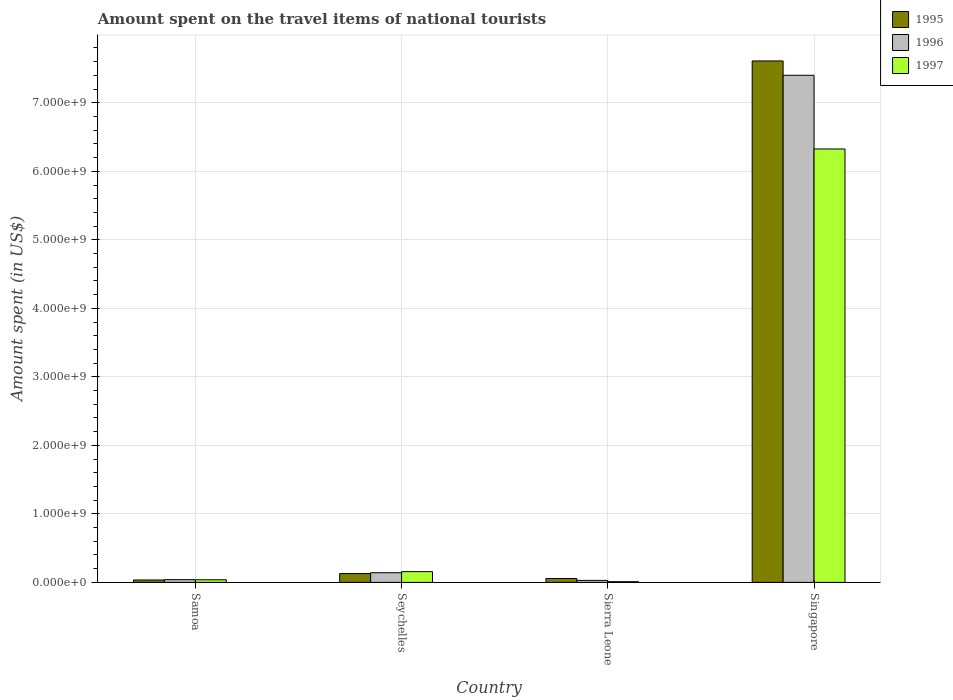Are the number of bars on each tick of the X-axis equal?
Offer a very short reply. Yes. How many bars are there on the 3rd tick from the left?
Make the answer very short. 3. What is the label of the 3rd group of bars from the left?
Keep it short and to the point. Sierra Leone. What is the amount spent on the travel items of national tourists in 1995 in Samoa?
Keep it short and to the point. 3.50e+07. Across all countries, what is the maximum amount spent on the travel items of national tourists in 1996?
Your answer should be very brief. 7.40e+09. Across all countries, what is the minimum amount spent on the travel items of national tourists in 1997?
Ensure brevity in your answer.  1.00e+07. In which country was the amount spent on the travel items of national tourists in 1995 maximum?
Your answer should be very brief. Singapore. In which country was the amount spent on the travel items of national tourists in 1997 minimum?
Offer a terse response. Sierra Leone. What is the total amount spent on the travel items of national tourists in 1995 in the graph?
Your answer should be very brief. 7.83e+09. What is the difference between the amount spent on the travel items of national tourists in 1997 in Samoa and that in Singapore?
Provide a short and direct response. -6.29e+09. What is the difference between the amount spent on the travel items of national tourists in 1996 in Sierra Leone and the amount spent on the travel items of national tourists in 1995 in Samoa?
Your response must be concise. -6.00e+06. What is the average amount spent on the travel items of national tourists in 1996 per country?
Provide a succinct answer. 1.90e+09. What is the difference between the amount spent on the travel items of national tourists of/in 1997 and amount spent on the travel items of national tourists of/in 1995 in Sierra Leone?
Keep it short and to the point. -4.70e+07. What is the ratio of the amount spent on the travel items of national tourists in 1995 in Seychelles to that in Sierra Leone?
Ensure brevity in your answer.  2.26. Is the amount spent on the travel items of national tourists in 1996 in Sierra Leone less than that in Singapore?
Ensure brevity in your answer.  Yes. What is the difference between the highest and the second highest amount spent on the travel items of national tourists in 1996?
Offer a terse response. 7.36e+09. What is the difference between the highest and the lowest amount spent on the travel items of national tourists in 1996?
Provide a short and direct response. 7.37e+09. Is the sum of the amount spent on the travel items of national tourists in 1997 in Samoa and Sierra Leone greater than the maximum amount spent on the travel items of national tourists in 1996 across all countries?
Offer a very short reply. No. What does the 2nd bar from the right in Singapore represents?
Provide a succinct answer. 1996. Is it the case that in every country, the sum of the amount spent on the travel items of national tourists in 1997 and amount spent on the travel items of national tourists in 1995 is greater than the amount spent on the travel items of national tourists in 1996?
Your answer should be very brief. Yes. Are all the bars in the graph horizontal?
Make the answer very short. No. What is the title of the graph?
Ensure brevity in your answer.  Amount spent on the travel items of national tourists. What is the label or title of the X-axis?
Provide a succinct answer. Country. What is the label or title of the Y-axis?
Provide a succinct answer. Amount spent (in US$). What is the Amount spent (in US$) in 1995 in Samoa?
Ensure brevity in your answer.  3.50e+07. What is the Amount spent (in US$) of 1996 in Samoa?
Keep it short and to the point. 4.00e+07. What is the Amount spent (in US$) of 1997 in Samoa?
Your response must be concise. 3.80e+07. What is the Amount spent (in US$) of 1995 in Seychelles?
Keep it short and to the point. 1.29e+08. What is the Amount spent (in US$) of 1996 in Seychelles?
Provide a short and direct response. 1.41e+08. What is the Amount spent (in US$) in 1997 in Seychelles?
Provide a short and direct response. 1.57e+08. What is the Amount spent (in US$) of 1995 in Sierra Leone?
Your response must be concise. 5.70e+07. What is the Amount spent (in US$) of 1996 in Sierra Leone?
Offer a very short reply. 2.90e+07. What is the Amount spent (in US$) of 1995 in Singapore?
Ensure brevity in your answer.  7.61e+09. What is the Amount spent (in US$) in 1996 in Singapore?
Provide a succinct answer. 7.40e+09. What is the Amount spent (in US$) in 1997 in Singapore?
Ensure brevity in your answer.  6.33e+09. Across all countries, what is the maximum Amount spent (in US$) in 1995?
Provide a short and direct response. 7.61e+09. Across all countries, what is the maximum Amount spent (in US$) in 1996?
Your answer should be very brief. 7.40e+09. Across all countries, what is the maximum Amount spent (in US$) of 1997?
Give a very brief answer. 6.33e+09. Across all countries, what is the minimum Amount spent (in US$) of 1995?
Your answer should be very brief. 3.50e+07. Across all countries, what is the minimum Amount spent (in US$) of 1996?
Offer a very short reply. 2.90e+07. What is the total Amount spent (in US$) of 1995 in the graph?
Provide a succinct answer. 7.83e+09. What is the total Amount spent (in US$) of 1996 in the graph?
Ensure brevity in your answer.  7.61e+09. What is the total Amount spent (in US$) of 1997 in the graph?
Keep it short and to the point. 6.53e+09. What is the difference between the Amount spent (in US$) of 1995 in Samoa and that in Seychelles?
Offer a very short reply. -9.40e+07. What is the difference between the Amount spent (in US$) in 1996 in Samoa and that in Seychelles?
Offer a very short reply. -1.01e+08. What is the difference between the Amount spent (in US$) of 1997 in Samoa and that in Seychelles?
Provide a short and direct response. -1.19e+08. What is the difference between the Amount spent (in US$) in 1995 in Samoa and that in Sierra Leone?
Your answer should be very brief. -2.20e+07. What is the difference between the Amount spent (in US$) of 1996 in Samoa and that in Sierra Leone?
Keep it short and to the point. 1.10e+07. What is the difference between the Amount spent (in US$) in 1997 in Samoa and that in Sierra Leone?
Your answer should be compact. 2.80e+07. What is the difference between the Amount spent (in US$) of 1995 in Samoa and that in Singapore?
Provide a succinct answer. -7.58e+09. What is the difference between the Amount spent (in US$) in 1996 in Samoa and that in Singapore?
Offer a terse response. -7.36e+09. What is the difference between the Amount spent (in US$) of 1997 in Samoa and that in Singapore?
Your answer should be compact. -6.29e+09. What is the difference between the Amount spent (in US$) of 1995 in Seychelles and that in Sierra Leone?
Offer a terse response. 7.20e+07. What is the difference between the Amount spent (in US$) in 1996 in Seychelles and that in Sierra Leone?
Your answer should be compact. 1.12e+08. What is the difference between the Amount spent (in US$) of 1997 in Seychelles and that in Sierra Leone?
Your answer should be very brief. 1.47e+08. What is the difference between the Amount spent (in US$) of 1995 in Seychelles and that in Singapore?
Give a very brief answer. -7.48e+09. What is the difference between the Amount spent (in US$) of 1996 in Seychelles and that in Singapore?
Offer a terse response. -7.26e+09. What is the difference between the Amount spent (in US$) in 1997 in Seychelles and that in Singapore?
Provide a succinct answer. -6.17e+09. What is the difference between the Amount spent (in US$) in 1995 in Sierra Leone and that in Singapore?
Offer a terse response. -7.55e+09. What is the difference between the Amount spent (in US$) in 1996 in Sierra Leone and that in Singapore?
Ensure brevity in your answer.  -7.37e+09. What is the difference between the Amount spent (in US$) in 1997 in Sierra Leone and that in Singapore?
Ensure brevity in your answer.  -6.32e+09. What is the difference between the Amount spent (in US$) of 1995 in Samoa and the Amount spent (in US$) of 1996 in Seychelles?
Your answer should be very brief. -1.06e+08. What is the difference between the Amount spent (in US$) of 1995 in Samoa and the Amount spent (in US$) of 1997 in Seychelles?
Make the answer very short. -1.22e+08. What is the difference between the Amount spent (in US$) in 1996 in Samoa and the Amount spent (in US$) in 1997 in Seychelles?
Your answer should be compact. -1.17e+08. What is the difference between the Amount spent (in US$) in 1995 in Samoa and the Amount spent (in US$) in 1997 in Sierra Leone?
Offer a terse response. 2.50e+07. What is the difference between the Amount spent (in US$) of 1996 in Samoa and the Amount spent (in US$) of 1997 in Sierra Leone?
Provide a succinct answer. 3.00e+07. What is the difference between the Amount spent (in US$) in 1995 in Samoa and the Amount spent (in US$) in 1996 in Singapore?
Offer a terse response. -7.37e+09. What is the difference between the Amount spent (in US$) of 1995 in Samoa and the Amount spent (in US$) of 1997 in Singapore?
Offer a terse response. -6.29e+09. What is the difference between the Amount spent (in US$) of 1996 in Samoa and the Amount spent (in US$) of 1997 in Singapore?
Your answer should be very brief. -6.29e+09. What is the difference between the Amount spent (in US$) in 1995 in Seychelles and the Amount spent (in US$) in 1997 in Sierra Leone?
Ensure brevity in your answer.  1.19e+08. What is the difference between the Amount spent (in US$) in 1996 in Seychelles and the Amount spent (in US$) in 1997 in Sierra Leone?
Your answer should be compact. 1.31e+08. What is the difference between the Amount spent (in US$) in 1995 in Seychelles and the Amount spent (in US$) in 1996 in Singapore?
Your answer should be compact. -7.27e+09. What is the difference between the Amount spent (in US$) of 1995 in Seychelles and the Amount spent (in US$) of 1997 in Singapore?
Give a very brief answer. -6.20e+09. What is the difference between the Amount spent (in US$) of 1996 in Seychelles and the Amount spent (in US$) of 1997 in Singapore?
Ensure brevity in your answer.  -6.18e+09. What is the difference between the Amount spent (in US$) of 1995 in Sierra Leone and the Amount spent (in US$) of 1996 in Singapore?
Make the answer very short. -7.34e+09. What is the difference between the Amount spent (in US$) of 1995 in Sierra Leone and the Amount spent (in US$) of 1997 in Singapore?
Give a very brief answer. -6.27e+09. What is the difference between the Amount spent (in US$) of 1996 in Sierra Leone and the Amount spent (in US$) of 1997 in Singapore?
Provide a succinct answer. -6.30e+09. What is the average Amount spent (in US$) of 1995 per country?
Offer a terse response. 1.96e+09. What is the average Amount spent (in US$) of 1996 per country?
Provide a short and direct response. 1.90e+09. What is the average Amount spent (in US$) of 1997 per country?
Your response must be concise. 1.63e+09. What is the difference between the Amount spent (in US$) in 1995 and Amount spent (in US$) in 1996 in Samoa?
Provide a short and direct response. -5.00e+06. What is the difference between the Amount spent (in US$) in 1996 and Amount spent (in US$) in 1997 in Samoa?
Offer a terse response. 2.00e+06. What is the difference between the Amount spent (in US$) in 1995 and Amount spent (in US$) in 1996 in Seychelles?
Provide a succinct answer. -1.20e+07. What is the difference between the Amount spent (in US$) in 1995 and Amount spent (in US$) in 1997 in Seychelles?
Offer a very short reply. -2.80e+07. What is the difference between the Amount spent (in US$) of 1996 and Amount spent (in US$) of 1997 in Seychelles?
Offer a very short reply. -1.60e+07. What is the difference between the Amount spent (in US$) in 1995 and Amount spent (in US$) in 1996 in Sierra Leone?
Offer a very short reply. 2.80e+07. What is the difference between the Amount spent (in US$) in 1995 and Amount spent (in US$) in 1997 in Sierra Leone?
Offer a terse response. 4.70e+07. What is the difference between the Amount spent (in US$) in 1996 and Amount spent (in US$) in 1997 in Sierra Leone?
Offer a terse response. 1.90e+07. What is the difference between the Amount spent (in US$) in 1995 and Amount spent (in US$) in 1996 in Singapore?
Give a very brief answer. 2.09e+08. What is the difference between the Amount spent (in US$) in 1995 and Amount spent (in US$) in 1997 in Singapore?
Ensure brevity in your answer.  1.28e+09. What is the difference between the Amount spent (in US$) of 1996 and Amount spent (in US$) of 1997 in Singapore?
Your answer should be very brief. 1.08e+09. What is the ratio of the Amount spent (in US$) in 1995 in Samoa to that in Seychelles?
Give a very brief answer. 0.27. What is the ratio of the Amount spent (in US$) of 1996 in Samoa to that in Seychelles?
Provide a succinct answer. 0.28. What is the ratio of the Amount spent (in US$) of 1997 in Samoa to that in Seychelles?
Make the answer very short. 0.24. What is the ratio of the Amount spent (in US$) in 1995 in Samoa to that in Sierra Leone?
Provide a short and direct response. 0.61. What is the ratio of the Amount spent (in US$) of 1996 in Samoa to that in Sierra Leone?
Your answer should be very brief. 1.38. What is the ratio of the Amount spent (in US$) in 1997 in Samoa to that in Sierra Leone?
Offer a terse response. 3.8. What is the ratio of the Amount spent (in US$) in 1995 in Samoa to that in Singapore?
Make the answer very short. 0. What is the ratio of the Amount spent (in US$) of 1996 in Samoa to that in Singapore?
Your answer should be compact. 0.01. What is the ratio of the Amount spent (in US$) in 1997 in Samoa to that in Singapore?
Provide a short and direct response. 0.01. What is the ratio of the Amount spent (in US$) of 1995 in Seychelles to that in Sierra Leone?
Offer a very short reply. 2.26. What is the ratio of the Amount spent (in US$) in 1996 in Seychelles to that in Sierra Leone?
Provide a short and direct response. 4.86. What is the ratio of the Amount spent (in US$) in 1997 in Seychelles to that in Sierra Leone?
Keep it short and to the point. 15.7. What is the ratio of the Amount spent (in US$) in 1995 in Seychelles to that in Singapore?
Provide a short and direct response. 0.02. What is the ratio of the Amount spent (in US$) of 1996 in Seychelles to that in Singapore?
Ensure brevity in your answer.  0.02. What is the ratio of the Amount spent (in US$) of 1997 in Seychelles to that in Singapore?
Provide a short and direct response. 0.02. What is the ratio of the Amount spent (in US$) of 1995 in Sierra Leone to that in Singapore?
Offer a very short reply. 0.01. What is the ratio of the Amount spent (in US$) in 1996 in Sierra Leone to that in Singapore?
Your answer should be very brief. 0. What is the ratio of the Amount spent (in US$) of 1997 in Sierra Leone to that in Singapore?
Provide a succinct answer. 0. What is the difference between the highest and the second highest Amount spent (in US$) of 1995?
Keep it short and to the point. 7.48e+09. What is the difference between the highest and the second highest Amount spent (in US$) in 1996?
Your answer should be very brief. 7.26e+09. What is the difference between the highest and the second highest Amount spent (in US$) in 1997?
Offer a terse response. 6.17e+09. What is the difference between the highest and the lowest Amount spent (in US$) of 1995?
Keep it short and to the point. 7.58e+09. What is the difference between the highest and the lowest Amount spent (in US$) of 1996?
Provide a short and direct response. 7.37e+09. What is the difference between the highest and the lowest Amount spent (in US$) of 1997?
Provide a succinct answer. 6.32e+09. 